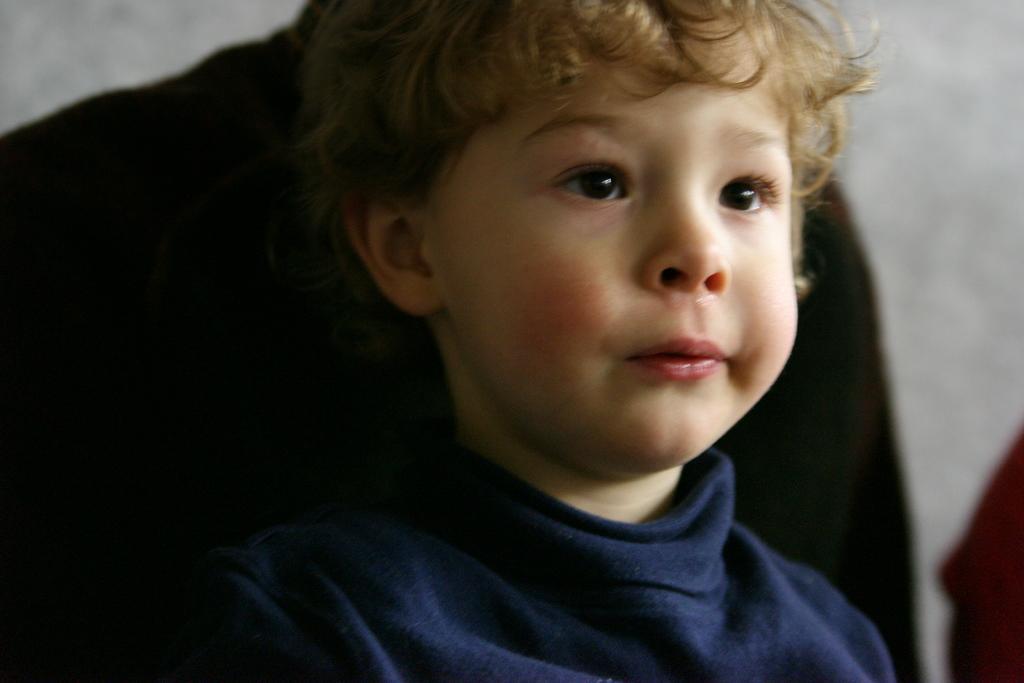Can you describe this image briefly? Here we can see a boy and he is looking right side of the image. Background it is blur. 